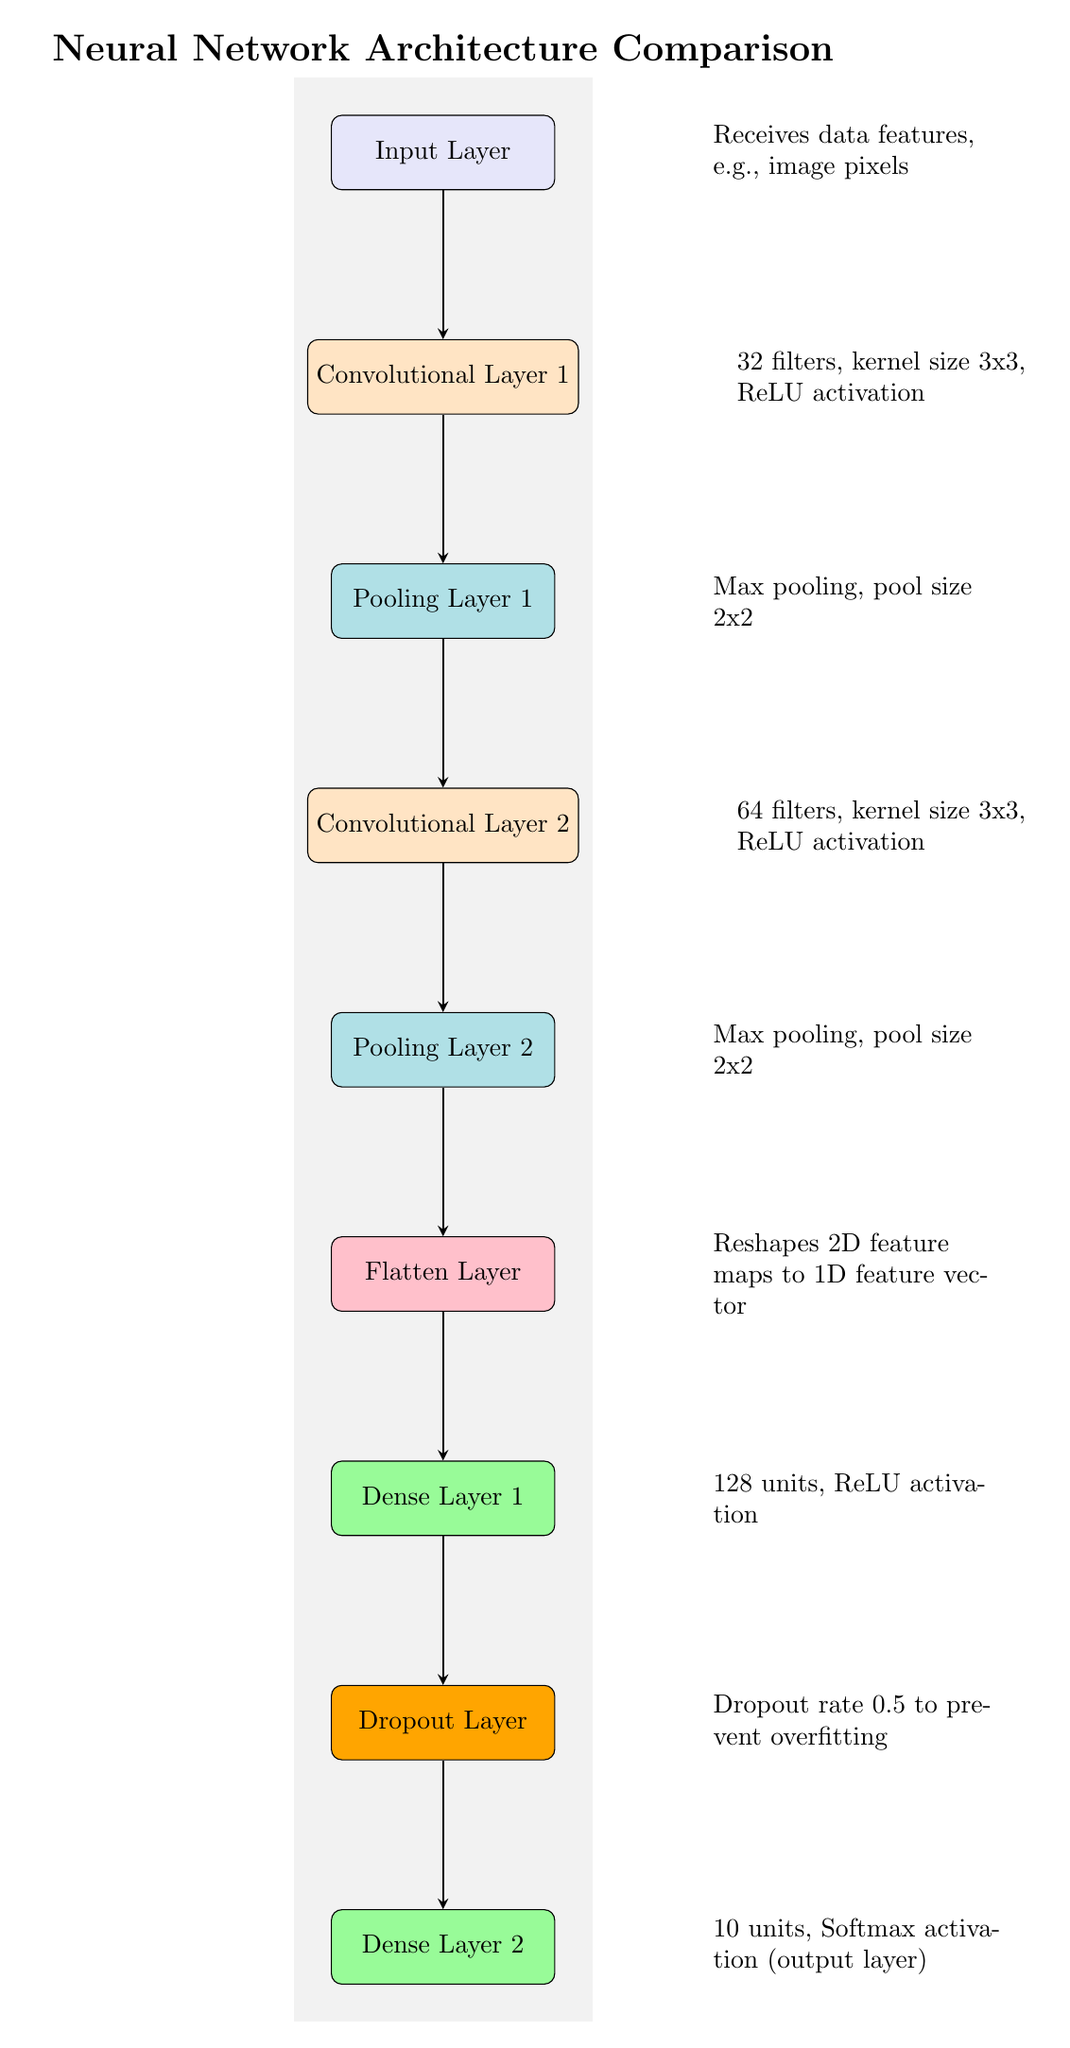What is the total number of layers in this neural network architecture? The diagram displays various layers, including the Input Layer, two Convolutional Layers, two Pooling Layers, a Flatten Layer, two Dense Layers, and a Dropout Layer, totaling eight distinct layers.
Answer: Eight What activation function is used in the first convolutional layer? The first convolutional layer, identified in the diagram, specifies that it employs the ReLU activation function as part of its description situated beside the layer.
Answer: ReLU How many filters does the second convolutional layer use? The diagram clearly shows that the second convolutional layer has 64 filters mentioned in its description, which can be located next to the layer in the visual.
Answer: Sixty-four What is the pooling size used in the first pooling layer? In the diagram, the first pooling layer is annotated with a description that states a pool size of 2x2, directly indicating the specific configuration employed for pooling operations in this layer.
Answer: Two by two What is the purpose of the dropout layer in this architecture? The dropout layer's description explicitly states that it serves to prevent overfitting with a dropout rate of 0.5, making it clear why this layer's functionality is important for the overall model performance.
Answer: Prevent overfitting What comes after the second pooling layer in the architecture? The flow of the diagram indicates that the Flatten Layer follows the second pooling layer, as the arrow directed from Pooling Layer 2 leads directly to the Flatten Layer, establishing a sequential relationship.
Answer: Flatten Layer How many units are there in the first dense layer? The description next to the first dense layer in the diagram specifies that there are 128 units in this layer, making it straightforward to identify its output dimensionality.
Answer: One hundred twenty-eight What is the output activation function of the final layer? The final layer, identified as Dense Layer 2 in the diagram, is annotated with a Softmax activation function, which defines how the final outputs are computed from the preceding layer's activations.
Answer: Softmax What type of layer is located directly before the output layer? The diagram structurally places the Dropout Layer immediately preceding the output layer, indicating the architectural role it plays in regularization just before final predictions are made.
Answer: Dropout Layer 